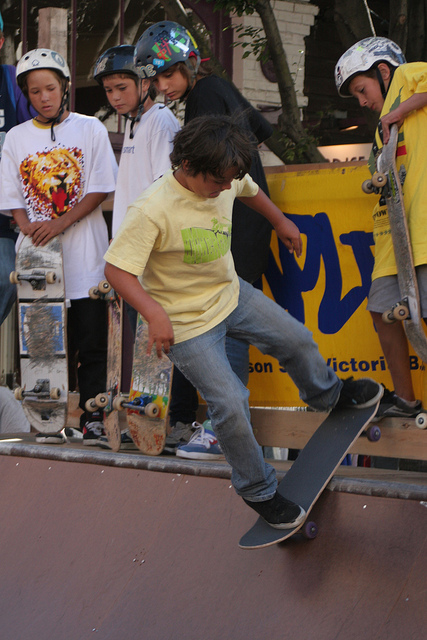Please identify all text content in this image. son Victori B 